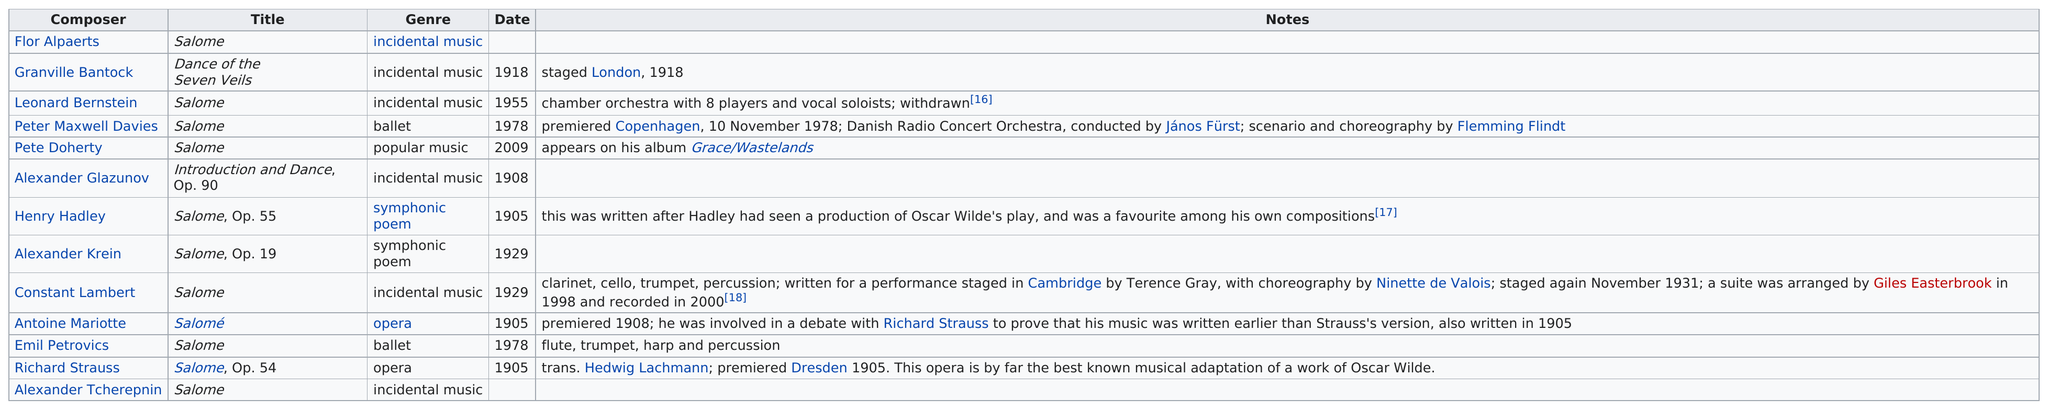Specify some key components in this picture. After Henry Hadley had seen an Oscar Wilde play, he wrote a piece of work titled "Salome, Op. 55. There are 11 works titled "Salome. The difference in years of work between Granville Bantock and Pete Doherty is 91 years. Out of the two symphonic poems, one is... Alexander Glazunov is listed below Pete Doherty in the composer's list. 